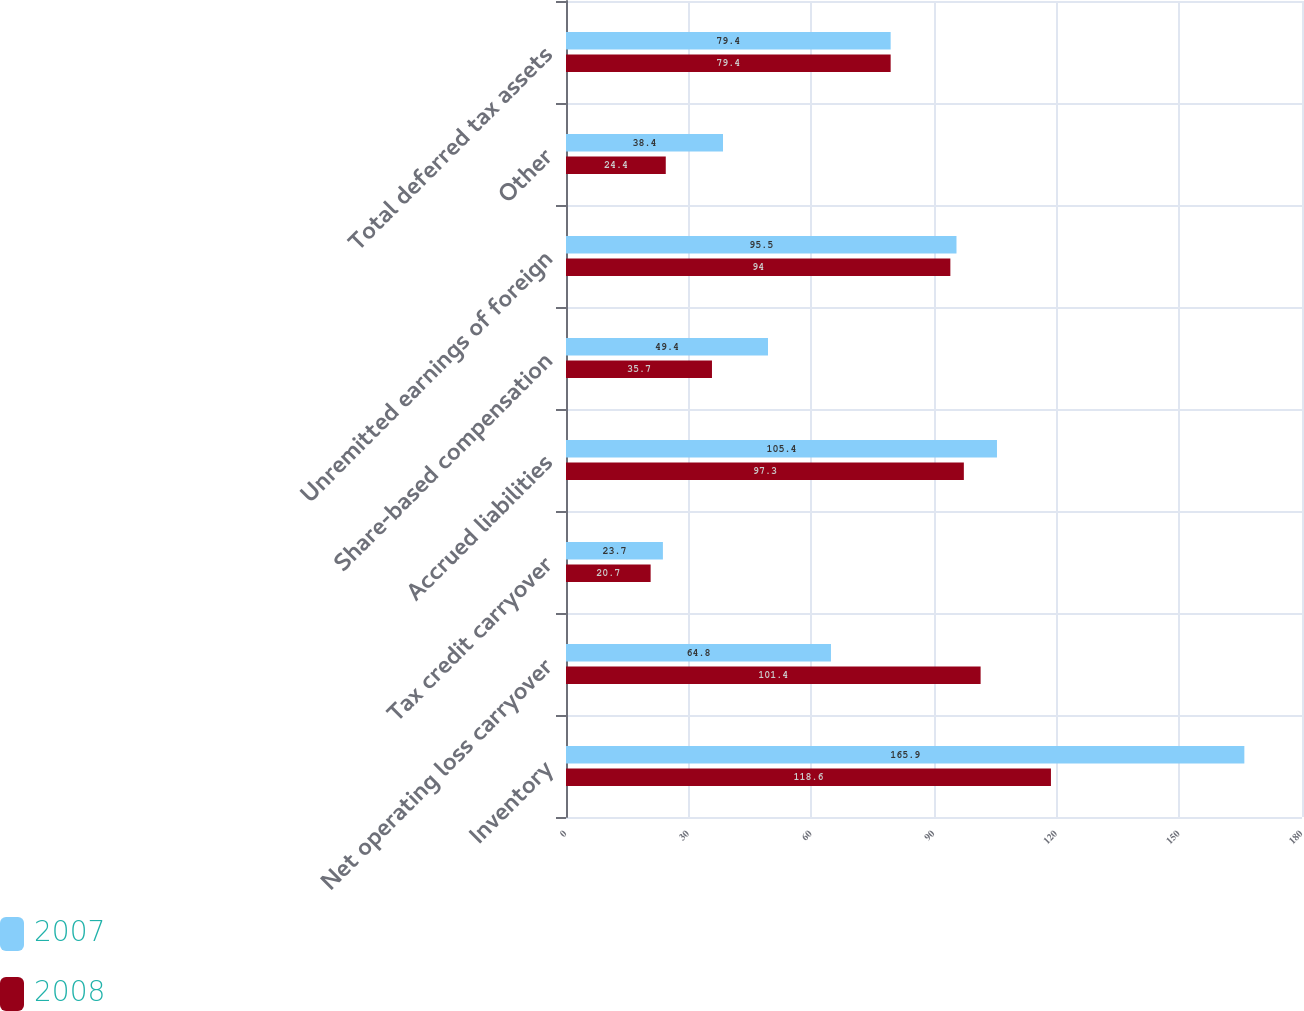Convert chart. <chart><loc_0><loc_0><loc_500><loc_500><stacked_bar_chart><ecel><fcel>Inventory<fcel>Net operating loss carryover<fcel>Tax credit carryover<fcel>Accrued liabilities<fcel>Share-based compensation<fcel>Unremitted earnings of foreign<fcel>Other<fcel>Total deferred tax assets<nl><fcel>2007<fcel>165.9<fcel>64.8<fcel>23.7<fcel>105.4<fcel>49.4<fcel>95.5<fcel>38.4<fcel>79.4<nl><fcel>2008<fcel>118.6<fcel>101.4<fcel>20.7<fcel>97.3<fcel>35.7<fcel>94<fcel>24.4<fcel>79.4<nl></chart> 